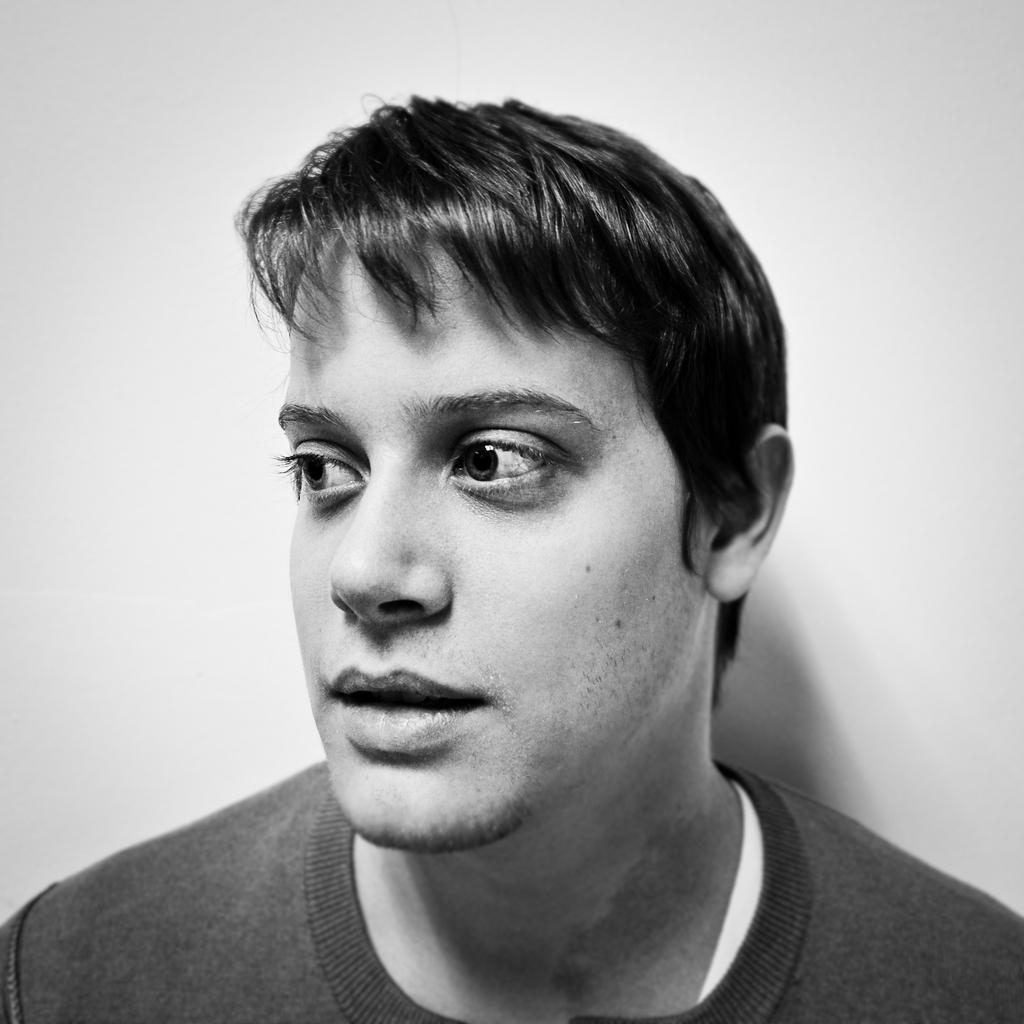In one or two sentences, can you explain what this image depicts? In this image I can see a person and background is white. 